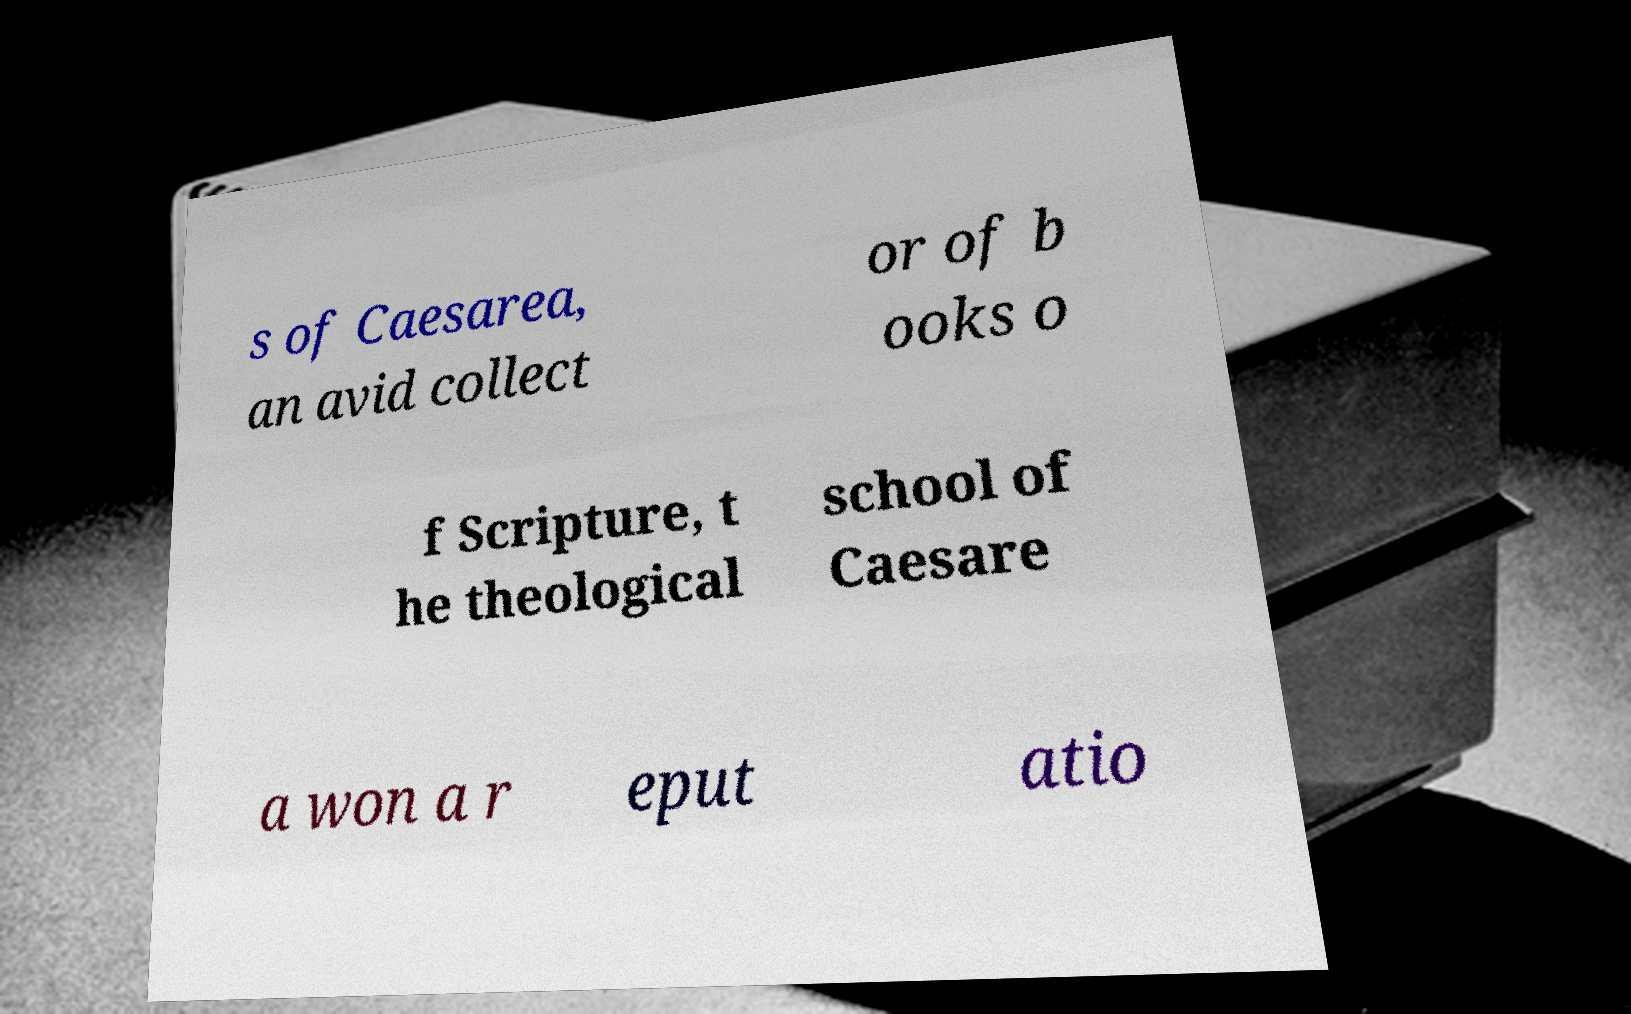Could you extract and type out the text from this image? s of Caesarea, an avid collect or of b ooks o f Scripture, t he theological school of Caesare a won a r eput atio 